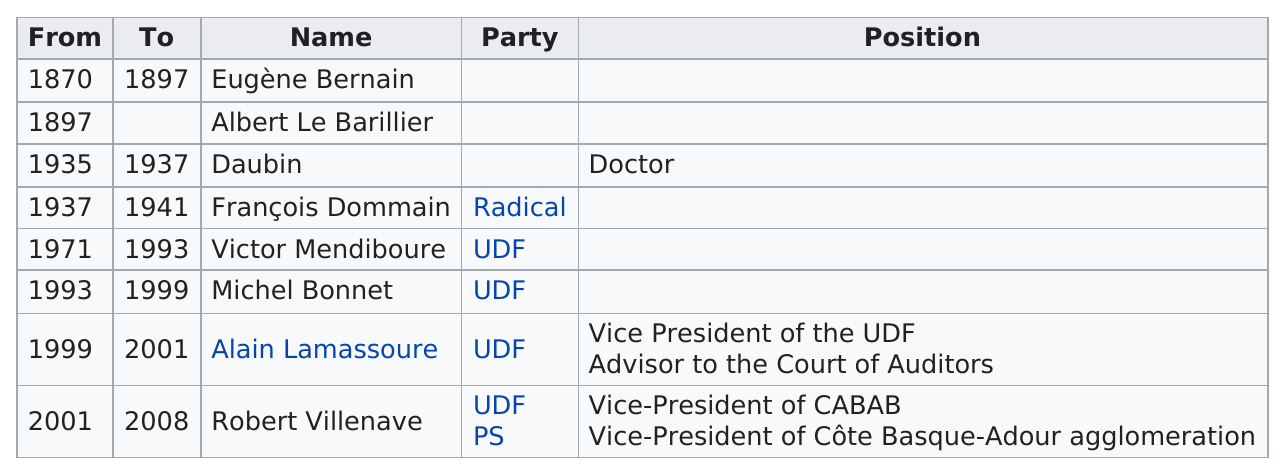Give some essential details in this illustration. The UDF party has had mayors who won elections, including Victor Mendiboure, Michel Bonnet, Alain Lamassoure, and Robert Villenave. Alain Lamassoure served as mayor for the shortest period of time among all the mayors. Daubin served in office for a period of two years. Alain Lamassoure served as the mayor of Anglet for the same number of years as Daubin. Eugène Bernain served the longest tenure as mayor among all the previous mayors. 